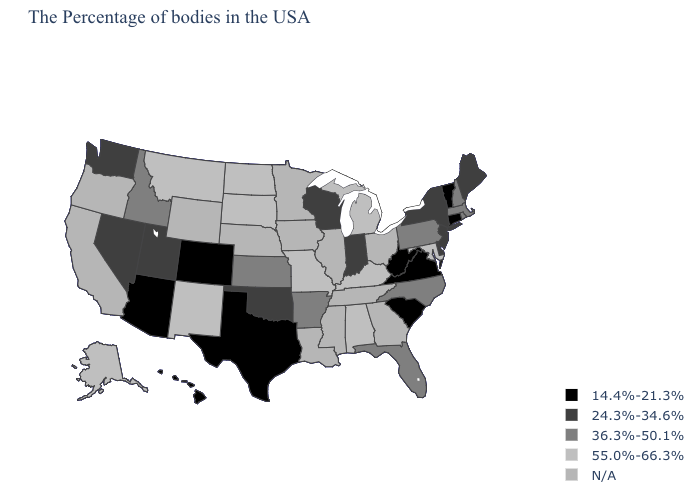Among the states that border New Jersey , does New York have the highest value?
Be succinct. No. Name the states that have a value in the range 55.0%-66.3%?
Write a very short answer. Maryland, Michigan, Kentucky, Alabama, Missouri, South Dakota, North Dakota, New Mexico, Montana, Alaska. What is the value of Indiana?
Keep it brief. 24.3%-34.6%. What is the value of Virginia?
Answer briefly. 14.4%-21.3%. What is the value of New Hampshire?
Concise answer only. 36.3%-50.1%. Among the states that border North Carolina , which have the lowest value?
Short answer required. Virginia, South Carolina. What is the value of Alabama?
Short answer required. 55.0%-66.3%. Name the states that have a value in the range 36.3%-50.1%?
Write a very short answer. Massachusetts, Rhode Island, New Hampshire, Pennsylvania, North Carolina, Florida, Arkansas, Kansas, Idaho. Name the states that have a value in the range 24.3%-34.6%?
Concise answer only. Maine, New York, New Jersey, Delaware, Indiana, Wisconsin, Oklahoma, Utah, Nevada, Washington. Does Kansas have the lowest value in the USA?
Short answer required. No. How many symbols are there in the legend?
Answer briefly. 5. Does New Jersey have the highest value in the USA?
Keep it brief. No. Does South Dakota have the highest value in the MidWest?
Concise answer only. Yes. 